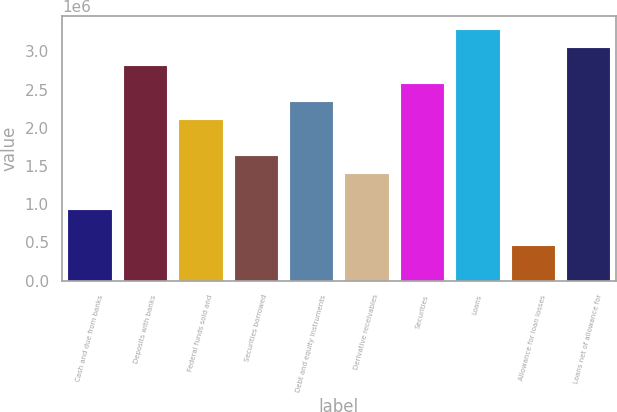Convert chart to OTSL. <chart><loc_0><loc_0><loc_500><loc_500><bar_chart><fcel>Cash and due from banks<fcel>Deposits with banks<fcel>Federal funds sold and<fcel>Securities borrowed<fcel>Debt and equity instruments<fcel>Derivative receivables<fcel>Securities<fcel>Loans<fcel>Allowance for loan losses<fcel>Loans net of allowance for<nl><fcel>941288<fcel>2.82183e+06<fcel>2.11663e+06<fcel>1.64649e+06<fcel>2.3517e+06<fcel>1.41142e+06<fcel>2.58677e+06<fcel>3.29197e+06<fcel>471152<fcel>3.0569e+06<nl></chart> 